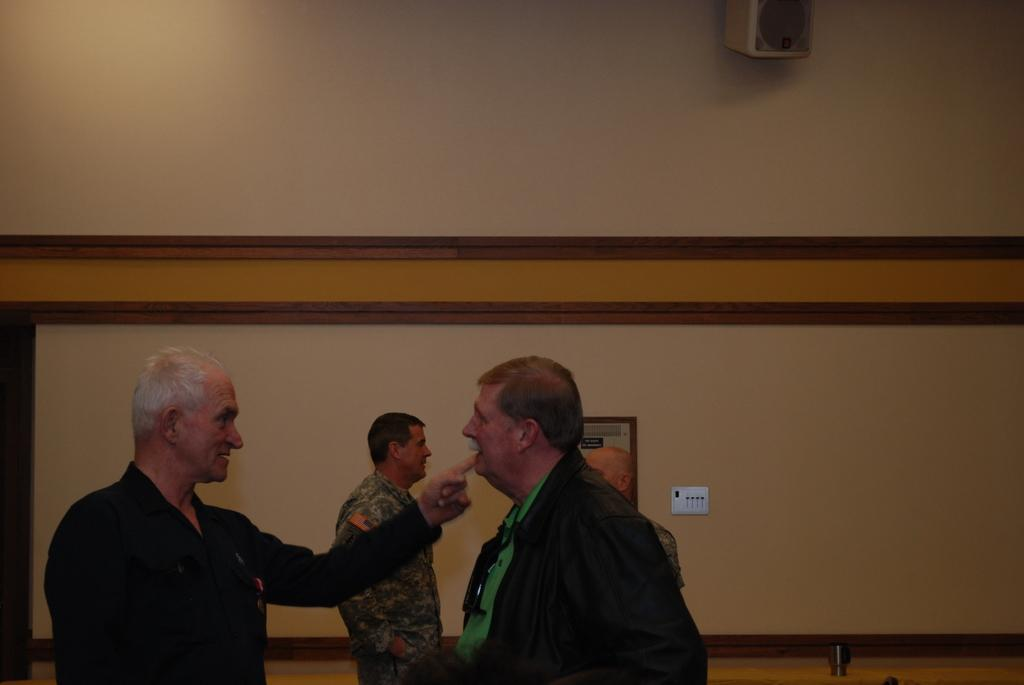How many people are in the image? There are four men in the image. What object can be seen in the image that is typically used for amplifying sound? There is a speaker in the image. What type of decorative item is present on the wall in the image? There is a frame on the wall in the image. Can you describe any other objects in the image besides the men, speaker, and frame? There are some unspecified objects in the image. What type of horn can be seen on the leg of one of the men in the image? There is no horn or any reference to a leg in the image; it only features four men, a speaker, and a frame on the wall. 